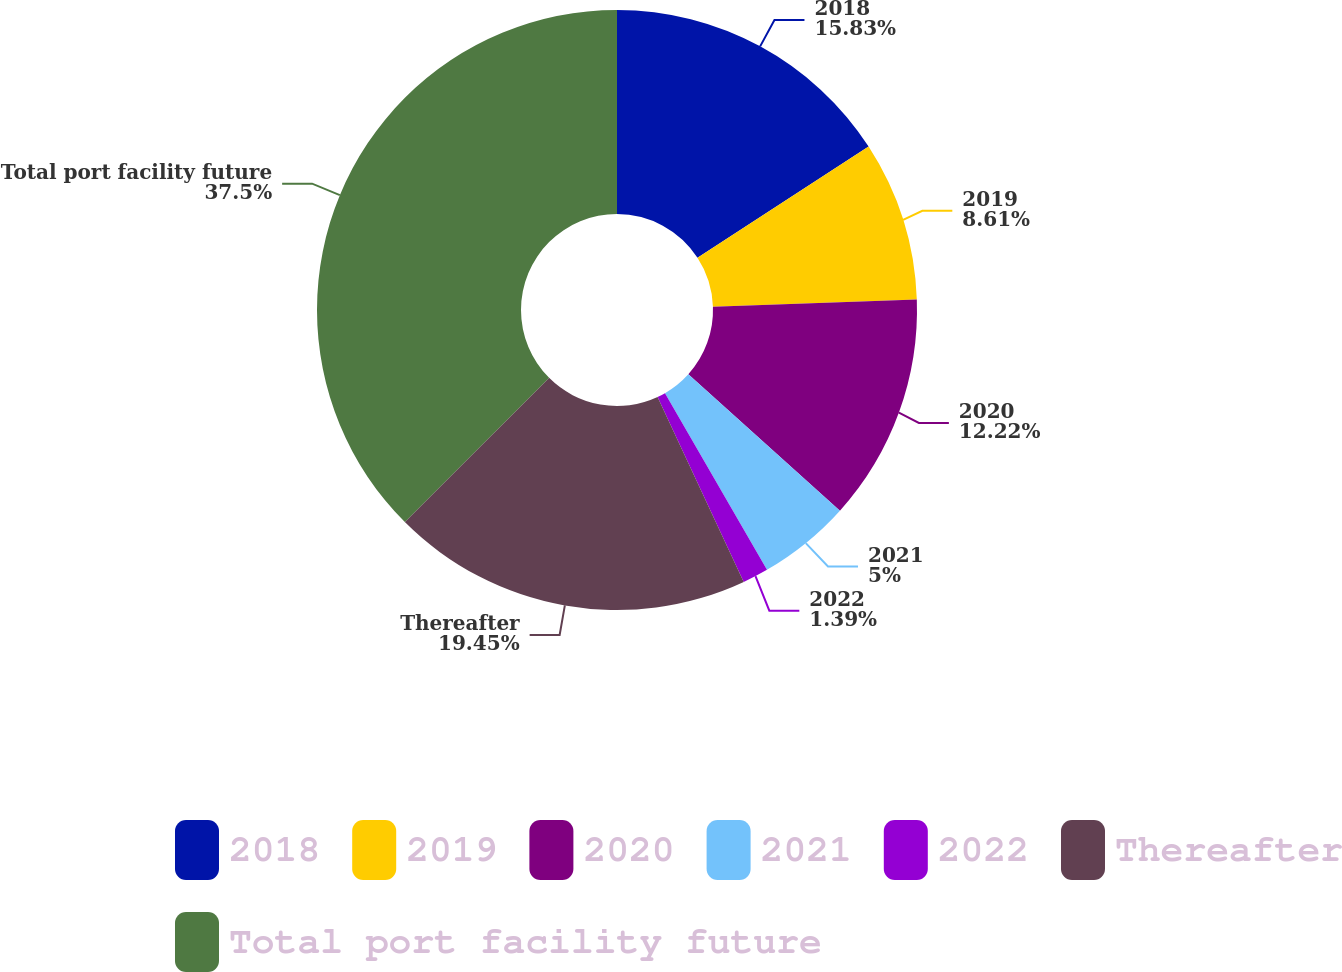Convert chart to OTSL. <chart><loc_0><loc_0><loc_500><loc_500><pie_chart><fcel>2018<fcel>2019<fcel>2020<fcel>2021<fcel>2022<fcel>Thereafter<fcel>Total port facility future<nl><fcel>15.83%<fcel>8.61%<fcel>12.22%<fcel>5.0%<fcel>1.39%<fcel>19.44%<fcel>37.49%<nl></chart> 